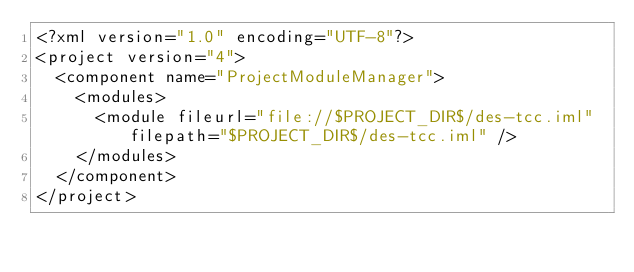Convert code to text. <code><loc_0><loc_0><loc_500><loc_500><_XML_><?xml version="1.0" encoding="UTF-8"?>
<project version="4">
  <component name="ProjectModuleManager">
    <modules>
      <module fileurl="file://$PROJECT_DIR$/des-tcc.iml" filepath="$PROJECT_DIR$/des-tcc.iml" />
    </modules>
  </component>
</project></code> 